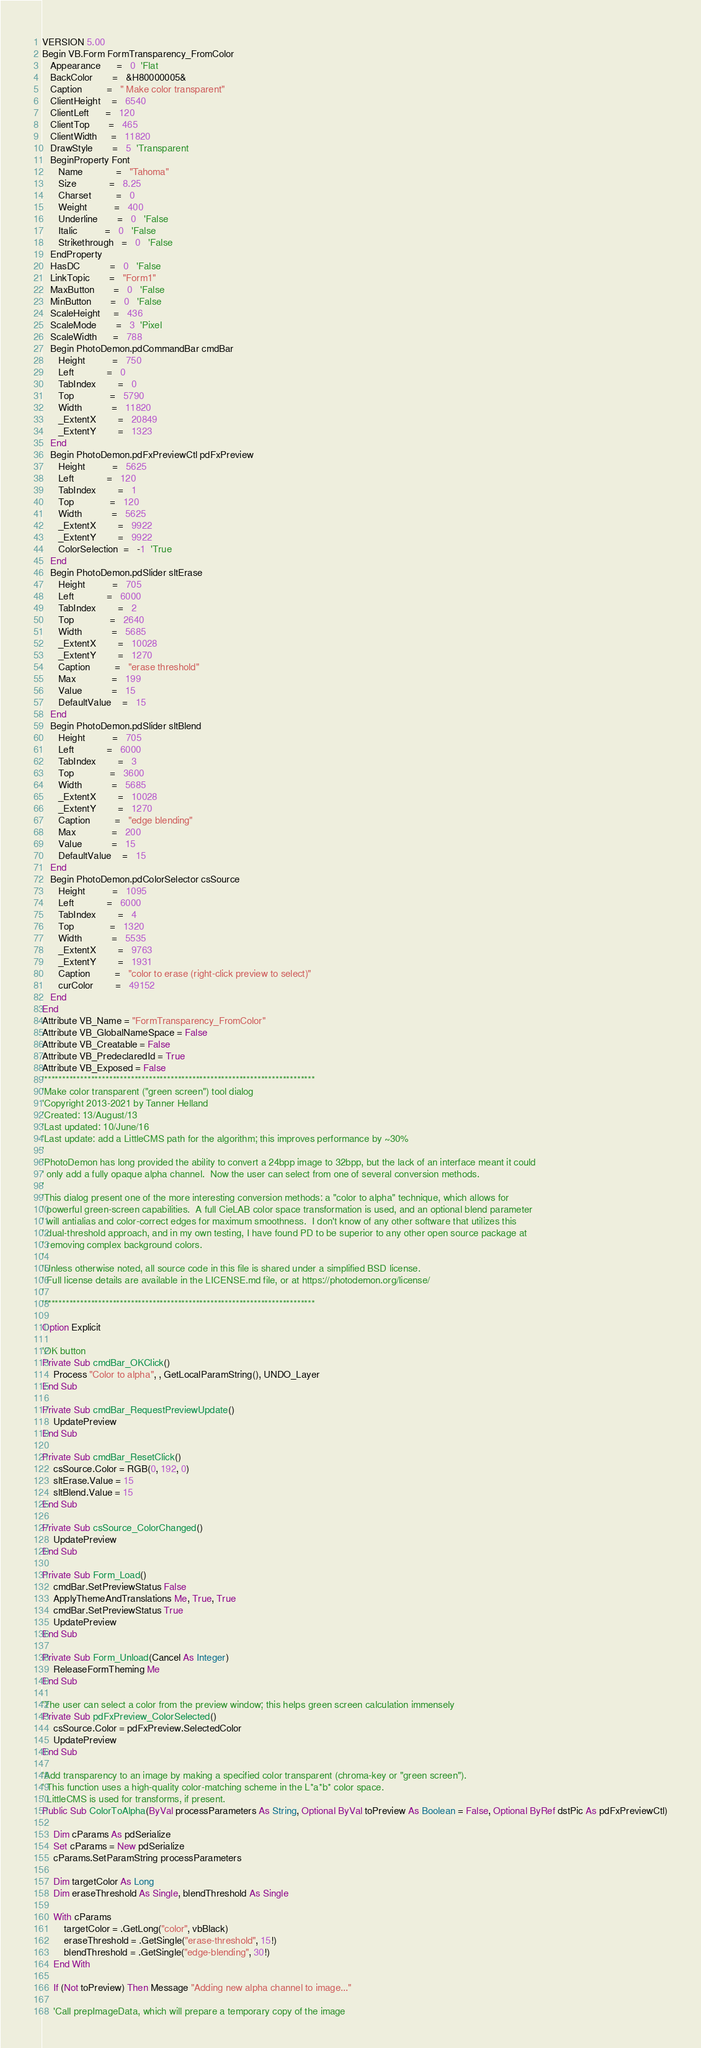Convert code to text. <code><loc_0><loc_0><loc_500><loc_500><_VisualBasic_>VERSION 5.00
Begin VB.Form FormTransparency_FromColor 
   Appearance      =   0  'Flat
   BackColor       =   &H80000005&
   Caption         =   " Make color transparent"
   ClientHeight    =   6540
   ClientLeft      =   120
   ClientTop       =   465
   ClientWidth     =   11820
   DrawStyle       =   5  'Transparent
   BeginProperty Font 
      Name            =   "Tahoma"
      Size            =   8.25
      Charset         =   0
      Weight          =   400
      Underline       =   0   'False
      Italic          =   0   'False
      Strikethrough   =   0   'False
   EndProperty
   HasDC           =   0   'False
   LinkTopic       =   "Form1"
   MaxButton       =   0   'False
   MinButton       =   0   'False
   ScaleHeight     =   436
   ScaleMode       =   3  'Pixel
   ScaleWidth      =   788
   Begin PhotoDemon.pdCommandBar cmdBar 
      Height          =   750
      Left            =   0
      TabIndex        =   0
      Top             =   5790
      Width           =   11820
      _ExtentX        =   20849
      _ExtentY        =   1323
   End
   Begin PhotoDemon.pdFxPreviewCtl pdFxPreview 
      Height          =   5625
      Left            =   120
      TabIndex        =   1
      Top             =   120
      Width           =   5625
      _ExtentX        =   9922
      _ExtentY        =   9922
      ColorSelection  =   -1  'True
   End
   Begin PhotoDemon.pdSlider sltErase 
      Height          =   705
      Left            =   6000
      TabIndex        =   2
      Top             =   2640
      Width           =   5685
      _ExtentX        =   10028
      _ExtentY        =   1270
      Caption         =   "erase threshold"
      Max             =   199
      Value           =   15
      DefaultValue    =   15
   End
   Begin PhotoDemon.pdSlider sltBlend 
      Height          =   705
      Left            =   6000
      TabIndex        =   3
      Top             =   3600
      Width           =   5685
      _ExtentX        =   10028
      _ExtentY        =   1270
      Caption         =   "edge blending"
      Max             =   200
      Value           =   15
      DefaultValue    =   15
   End
   Begin PhotoDemon.pdColorSelector csSource 
      Height          =   1095
      Left            =   6000
      TabIndex        =   4
      Top             =   1320
      Width           =   5535
      _ExtentX        =   9763
      _ExtentY        =   1931
      Caption         =   "color to erase (right-click preview to select)"
      curColor        =   49152
   End
End
Attribute VB_Name = "FormTransparency_FromColor"
Attribute VB_GlobalNameSpace = False
Attribute VB_Creatable = False
Attribute VB_PredeclaredId = True
Attribute VB_Exposed = False
'***************************************************************************
'Make color transparent ("green screen") tool dialog
'Copyright 2013-2021 by Tanner Helland
'Created: 13/August/13
'Last updated: 10/June/16
'Last update: add a LittleCMS path for the algorithm; this improves performance by ~30%
'
'PhotoDemon has long provided the ability to convert a 24bpp image to 32bpp, but the lack of an interface meant it could
' only add a fully opaque alpha channel.  Now the user can select from one of several conversion methods.
'
'This dialog present one of the more interesting conversion methods: a "color to alpha" technique, which allows for
' powerful green-screen capabilities.  A full CieLAB color space transformation is used, and an optional blend parameter
' will antialias and color-correct edges for maximum smoothness.  I don't know of any other software that utilizes this
' dual-threshold approach, and in my own testing, I have found PD to be superior to any other open source package at
' removing complex background colors.
'
'Unless otherwise noted, all source code in this file is shared under a simplified BSD license.
' Full license details are available in the LICENSE.md file, or at https://photodemon.org/license/
'
'***************************************************************************

Option Explicit

'OK button
Private Sub cmdBar_OKClick()
    Process "Color to alpha", , GetLocalParamString(), UNDO_Layer
End Sub

Private Sub cmdBar_RequestPreviewUpdate()
    UpdatePreview
End Sub

Private Sub cmdBar_ResetClick()
    csSource.Color = RGB(0, 192, 0)
    sltErase.Value = 15
    sltBlend.Value = 15
End Sub

Private Sub csSource_ColorChanged()
    UpdatePreview
End Sub

Private Sub Form_Load()
    cmdBar.SetPreviewStatus False
    ApplyThemeAndTranslations Me, True, True
    cmdBar.SetPreviewStatus True
    UpdatePreview
End Sub

Private Sub Form_Unload(Cancel As Integer)
    ReleaseFormTheming Me
End Sub

'The user can select a color from the preview window; this helps green screen calculation immensely
Private Sub pdFxPreview_ColorSelected()
    csSource.Color = pdFxPreview.SelectedColor
    UpdatePreview
End Sub

'Add transparency to an image by making a specified color transparent (chroma-key or "green screen").
' This function uses a high-quality color-matching scheme in the L*a*b* color space.
' LittleCMS is used for transforms, if present.
Public Sub ColorToAlpha(ByVal processParameters As String, Optional ByVal toPreview As Boolean = False, Optional ByRef dstPic As pdFxPreviewCtl)
    
    Dim cParams As pdSerialize
    Set cParams = New pdSerialize
    cParams.SetParamString processParameters
    
    Dim targetColor As Long
    Dim eraseThreshold As Single, blendThreshold As Single
    
    With cParams
        targetColor = .GetLong("color", vbBlack)
        eraseThreshold = .GetSingle("erase-threshold", 15!)
        blendThreshold = .GetSingle("edge-blending", 30!)
    End With
    
    If (Not toPreview) Then Message "Adding new alpha channel to image..."
    
    'Call prepImageData, which will prepare a temporary copy of the image</code> 